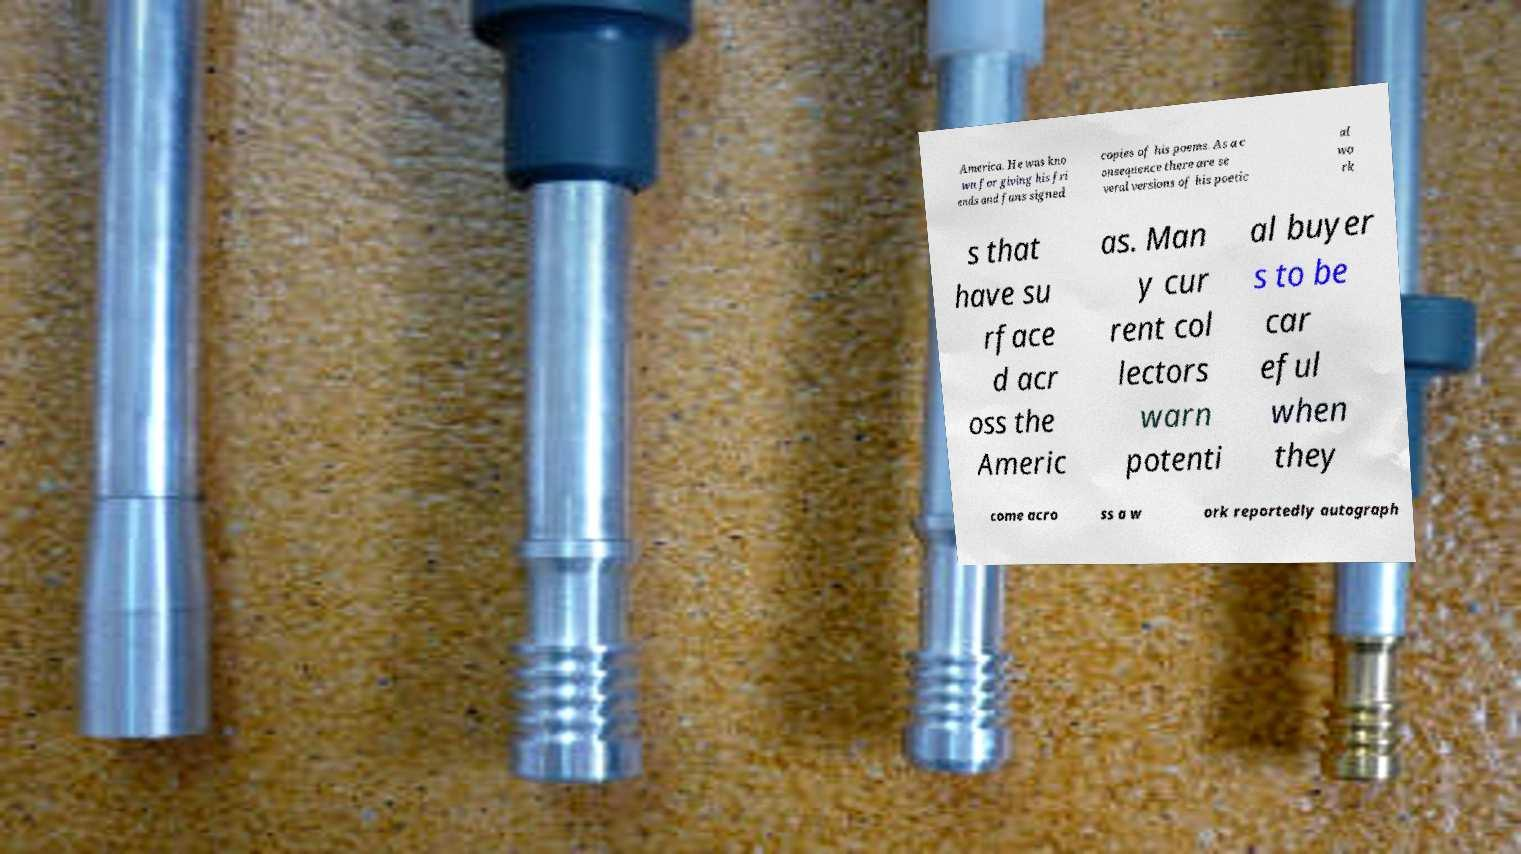I need the written content from this picture converted into text. Can you do that? America. He was kno wn for giving his fri ends and fans signed copies of his poems. As a c onsequence there are se veral versions of his poetic al wo rk s that have su rface d acr oss the Americ as. Man y cur rent col lectors warn potenti al buyer s to be car eful when they come acro ss a w ork reportedly autograph 